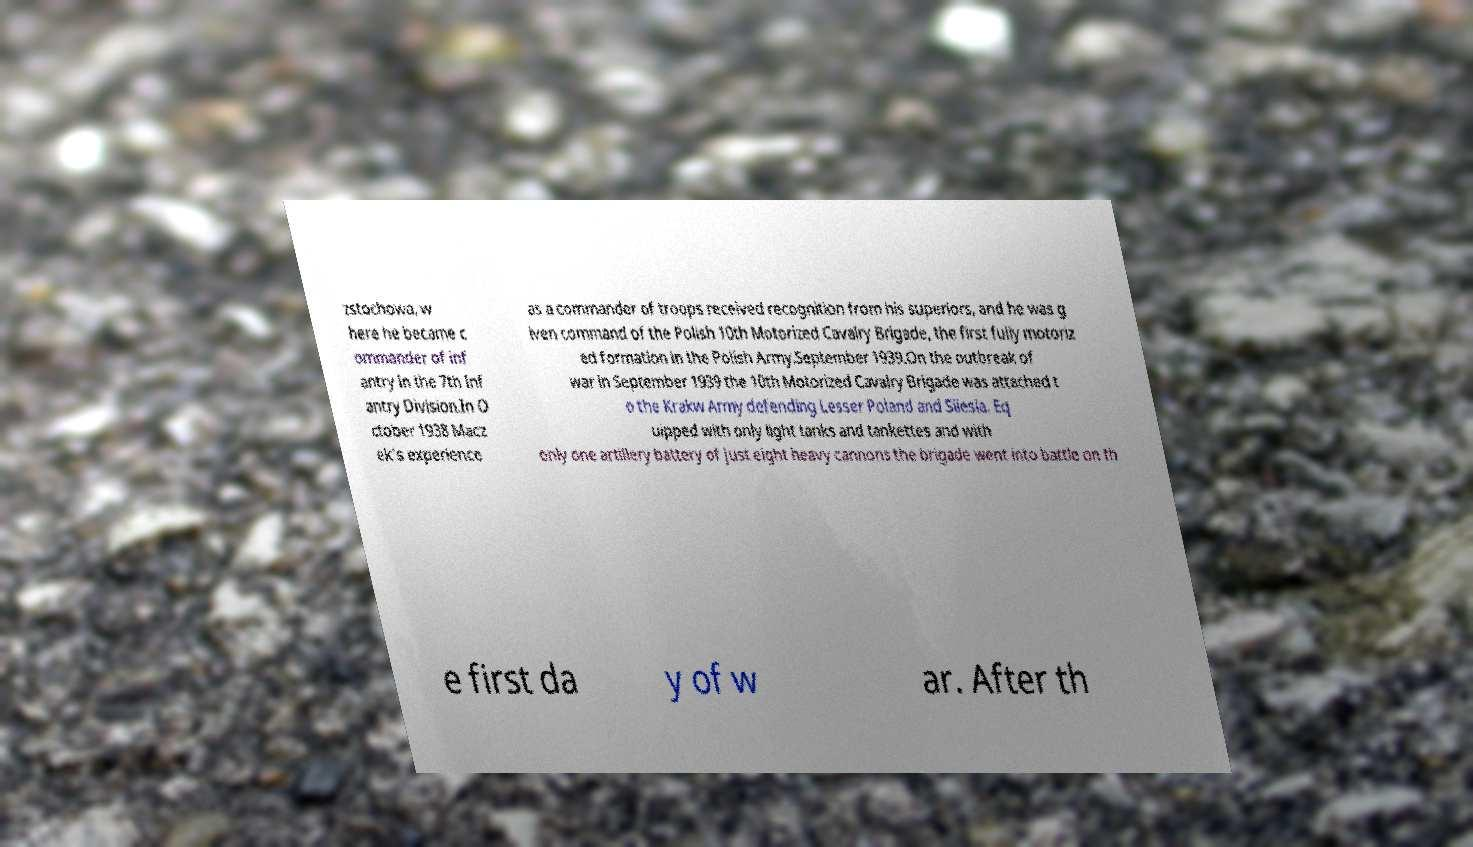Please read and relay the text visible in this image. What does it say? zstochowa, w here he became c ommander of inf antry in the 7th Inf antry Division.In O ctober 1938 Macz ek's experience as a commander of troops received recognition from his superiors, and he was g iven command of the Polish 10th Motorized Cavalry Brigade, the first fully motoriz ed formation in the Polish Army.September 1939.On the outbreak of war in September 1939 the 10th Motorized Cavalry Brigade was attached t o the Krakw Army defending Lesser Poland and Silesia. Eq uipped with only light tanks and tankettes and with only one artillery battery of just eight heavy cannons the brigade went into battle on th e first da y of w ar. After th 